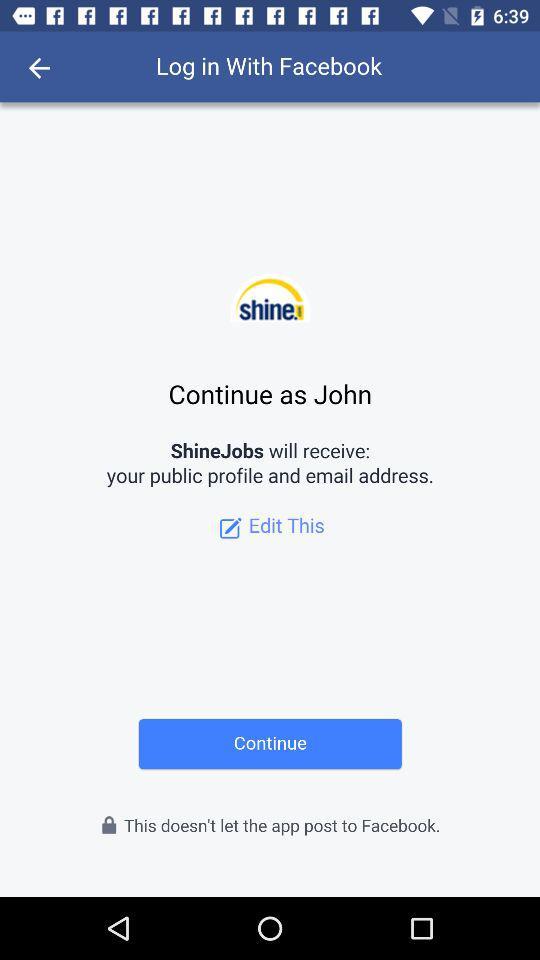What application will receive my public profile and email address? Your public profile and email address will be received by "ShineJobs". 